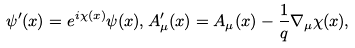<formula> <loc_0><loc_0><loc_500><loc_500>\psi ^ { \prime } ( x ) = e ^ { i \chi ( x ) } \psi ( x ) , A _ { \mu } ^ { \prime } ( x ) = A _ { \mu } ( x ) - \frac { 1 } { q } \nabla _ { \mu } \chi ( x ) ,</formula> 